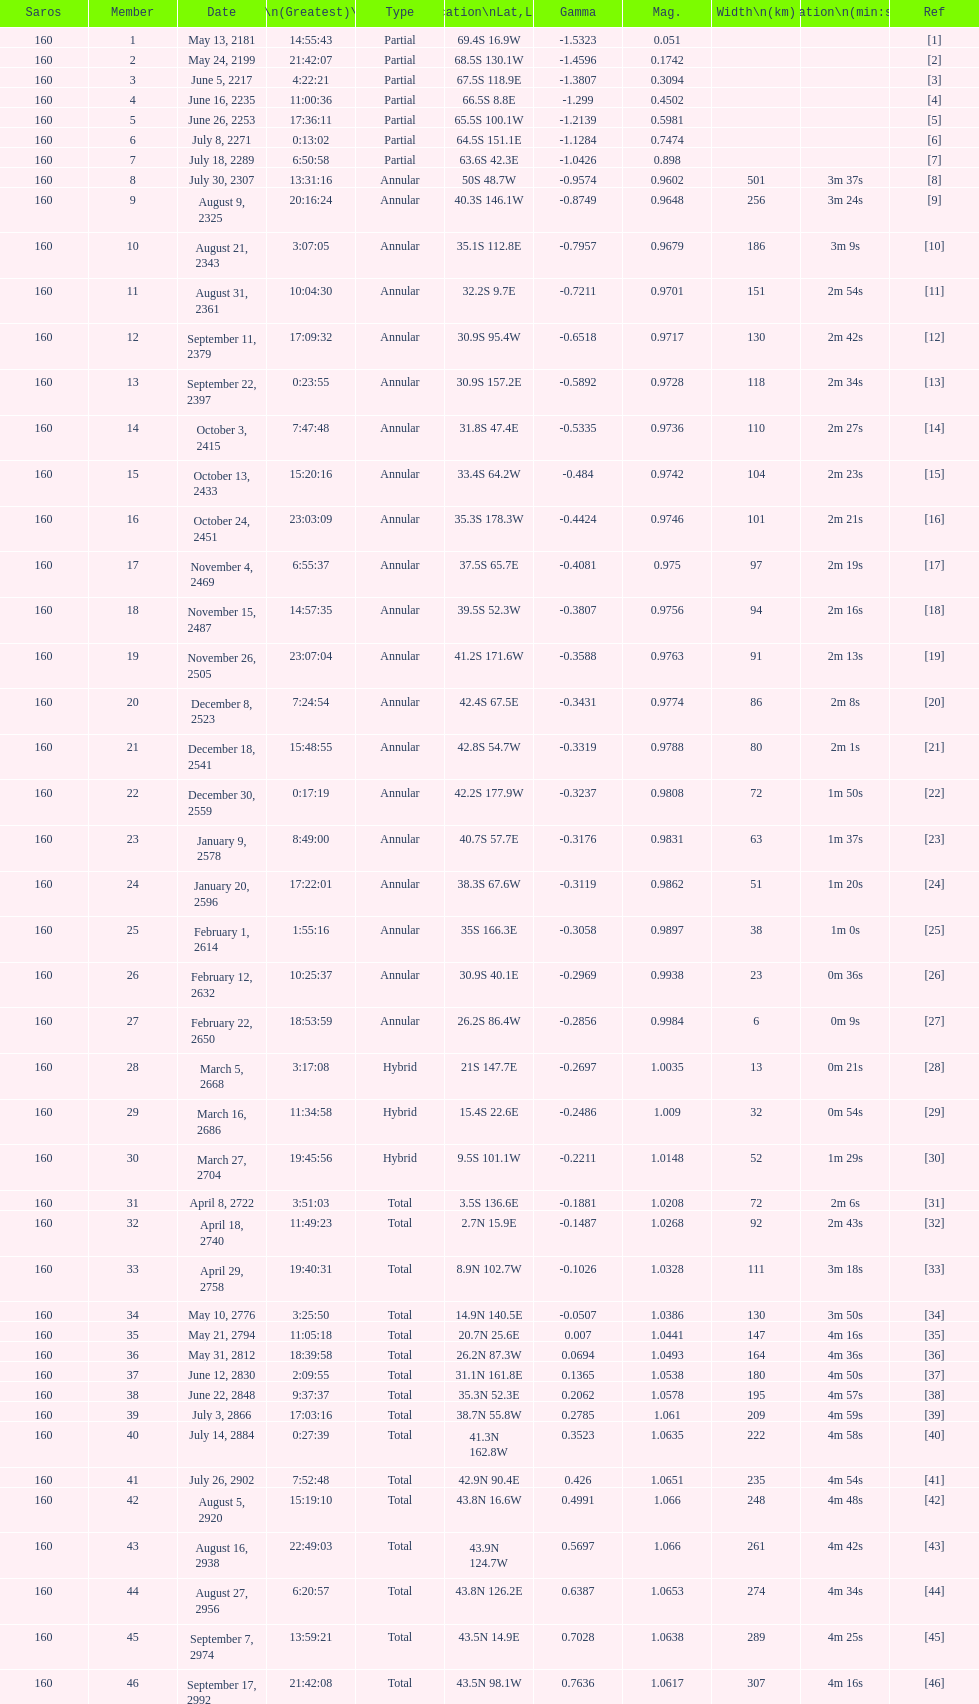In all, how many events will transpire? 46. 